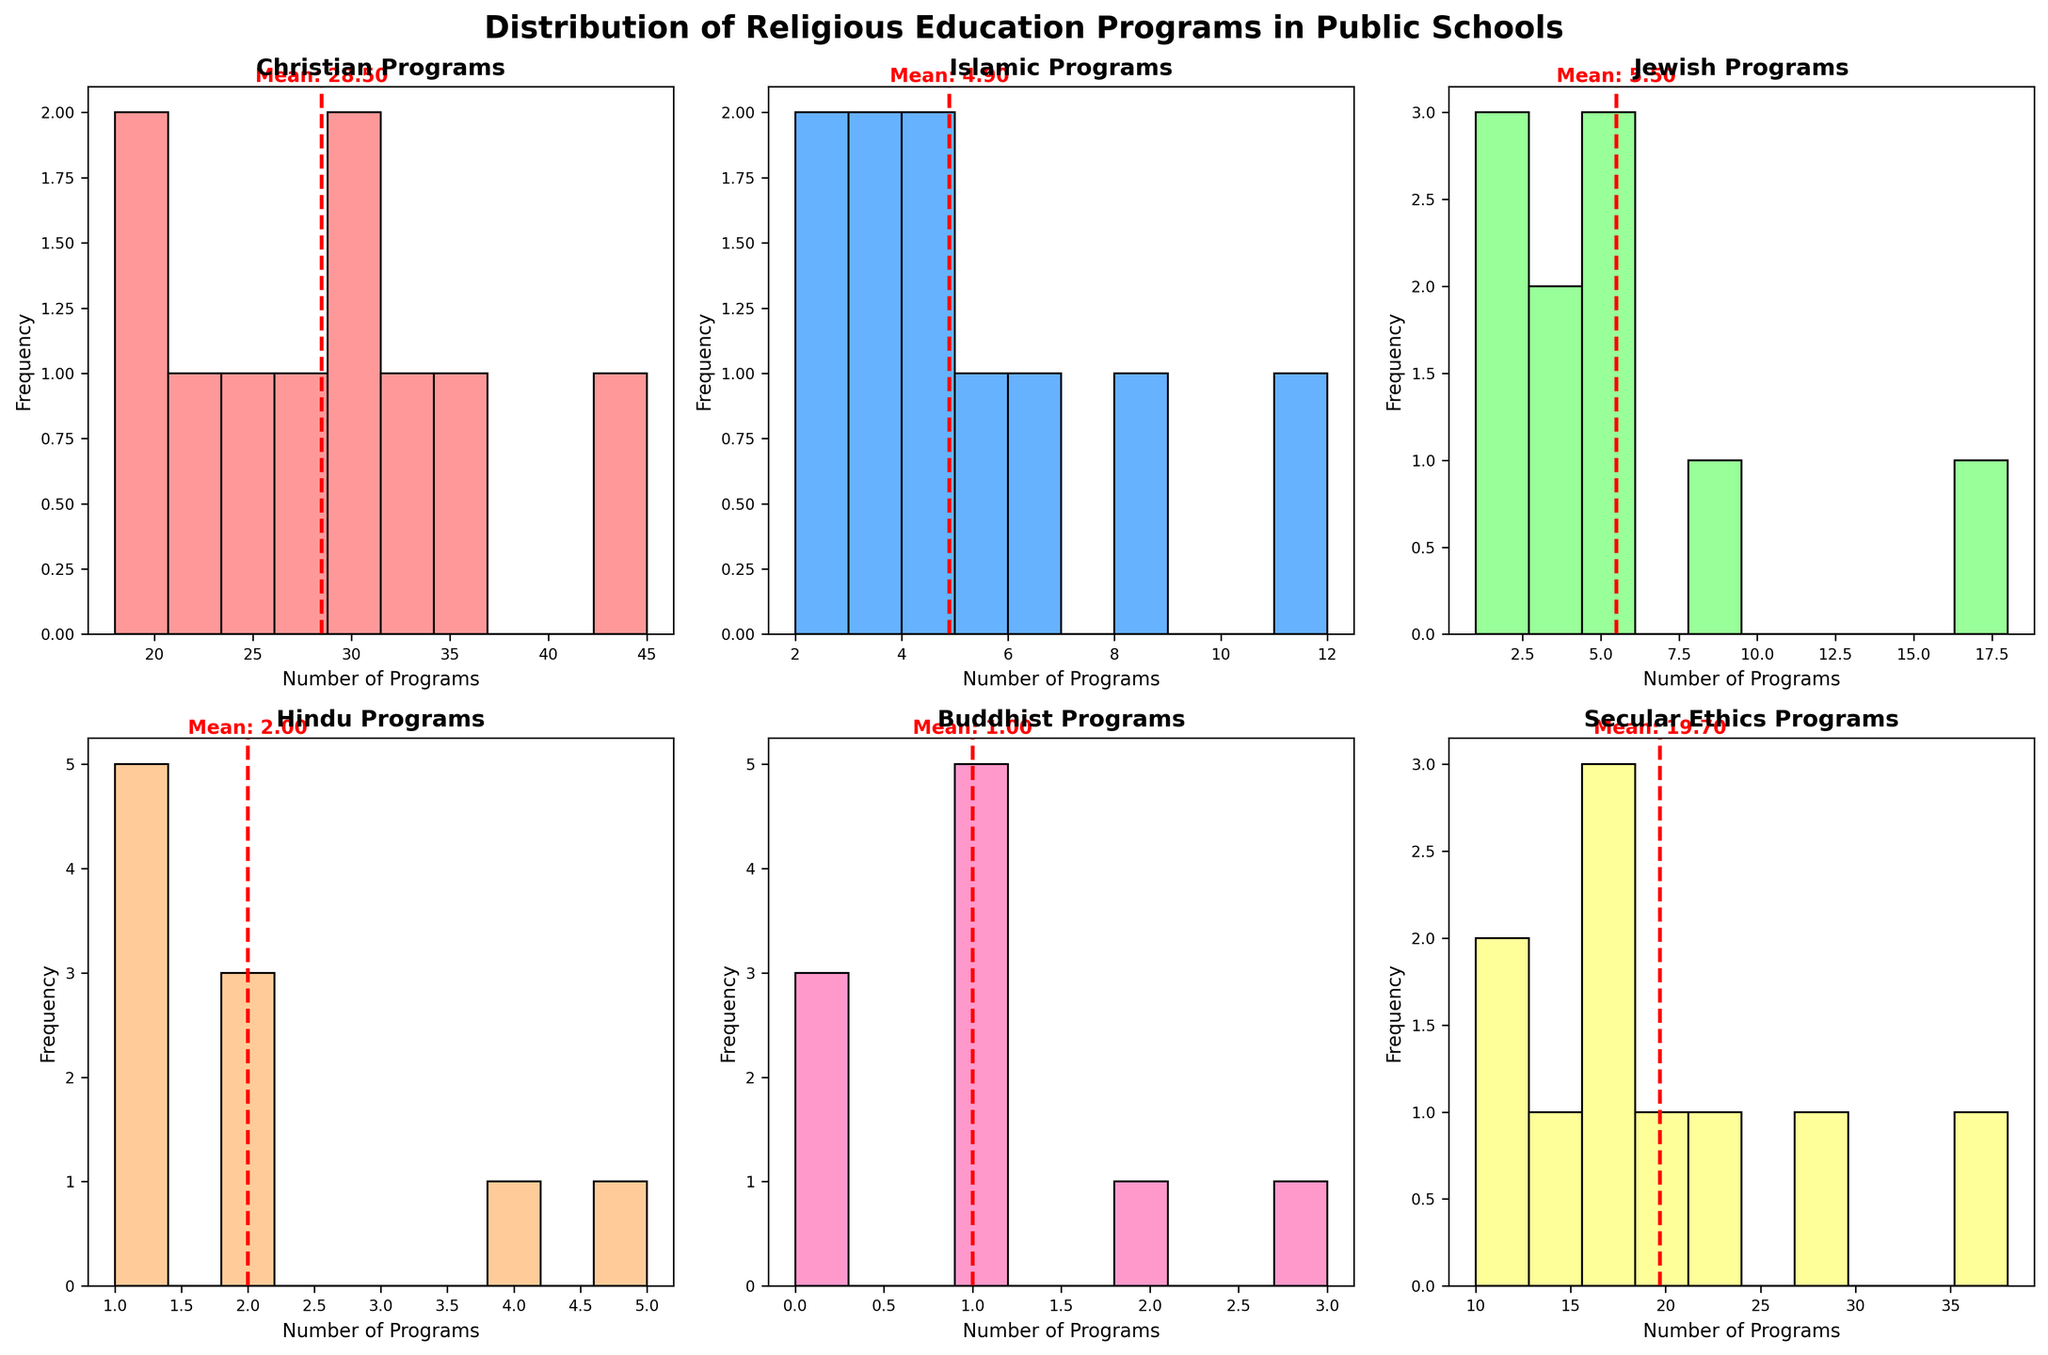What is the title of the figure? The title of the figure is presented at the top of the figure with larger, bold font.
Answer: Distribution of Religious Education Programs in Public Schools What is the average number of Christian Programs in the school districts? For the subplot representing Christian Programs, the average value is indicated by a red dashed line and labeled with text.
Answer: 28.50 How many bins are used in the histogram for Islamic Programs? Count the number of rectangles (bins) in the histogram for the Islamic Programs subplot.
Answer: 10 Which school district has the maximum number of Jewish Programs, according to the histogram? Identify the histogram for Jewish Programs, locate the bin with the highest value, and cross-reference with the school district data to find the school district.
Answer: New York City Between Secular Ethics Programs and Buddhist Programs, which has a higher average number of programs across school districts? Compare the red dashed mean lines in the subplots of Secular Ethics Programs and Buddhist Programs to determine which is higher.
Answer: Secular Ethics Programs What is the difference between the maximum and minimum number of Hindu Programs across the school districts? Find the maximum and minimum values in the histogram for Hindu Programs, calculate the difference between these values.
Answer: 5 - 1 = 4 Which histogram has the smallest range of data values? Find the range (difference between maximum and minimum values) for each histogram and identify the smallest range.
Answer: Buddhist Programs How do the number of school districts offering secular ethics programs compare to those offering Islamic programs? Refer to the histograms for both Secular Ethics Programs and Islamic Programs, count the number of school districts represented in each and compare these counts.
Answer: More districts offer secular ethics programs than Islamic programs What is the mode of the number of Buddhist Programs across school districts? Locate the bin in the Buddhist Programs histogram that has the highest frequency (mode).
Answer: 1 Which program type shows the most variety in the number of programs offered across different school districts? Compare the spread and range of the different histograms, noting which one has the widest spread of data values.
Answer: Christian Programs 